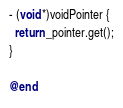<code> <loc_0><loc_0><loc_500><loc_500><_ObjectiveC_>- (void *)voidPointer {
  return _pointer.get();
}

@end
</code> 